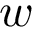<formula> <loc_0><loc_0><loc_500><loc_500>w</formula> 